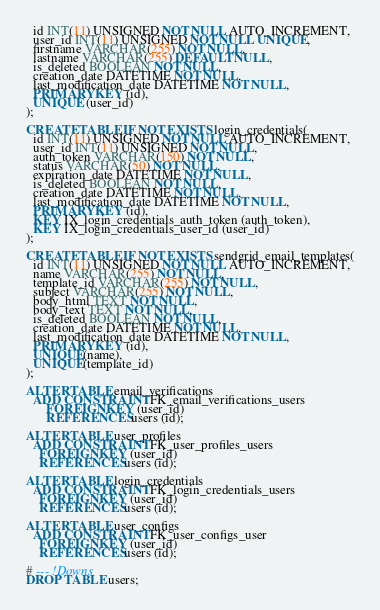<code> <loc_0><loc_0><loc_500><loc_500><_SQL_>  id INT(11) UNSIGNED NOT NULL AUTO_INCREMENT,
  user_id INT(11) UNSIGNED NOT NULL UNIQUE,
  firstname VARCHAR(255) NOT NULL,
  lastname VARCHAR(255) DEFAULT NULL,
  is_deleted BOOLEAN NOT NULL,
  creation_date DATETIME NOT NULL,
  last_modification_date DATETIME NOT NULL,
  PRIMARY KEY (id),
  UNIQUE (user_id)
);

CREATE TABLE IF NOT EXISTS login_credentials(
  id INT(11) UNSIGNED NOT NULL AUTO_INCREMENT,
  user_id INT(11) UNSIGNED NOT NULL,
  auth_token VARCHAR(150) NOT NULL,
  status VARCHAR(50) NOT NULL,
  expiration_date DATETIME NOT NULL,
  is_deleted BOOLEAN NOT NULL,
  creation_date DATETIME NOT NULL,
  last_modification_date DATETIME NOT NULL,
  PRIMARY KEY (id),
  KEY IX_login_credentials_auth_token (auth_token),
  KEY IX_login_credentials_user_id (user_id)
);

CREATE TABLE IF NOT EXISTS sendgrid_email_templates(
  id INT(11) UNSIGNED NOT NULL AUTO_INCREMENT,
  name VARCHAR(255) NOT NULL,
  template_id VARCHAR(255) NOT NULL,
  subject VARCHAR(255) NOT NULL,
  body_html TEXT NOT NULL,
  body_text TEXT NOT NULL,
  is_deleted BOOLEAN NOT NULL,
  creation_date DATETIME NOT NULL,
  last_modification_date DATETIME NOT NULL,
  PRIMARY KEY (id),
  UNIQUE(name),
  UNIQUE(template_id)
);

ALTER TABLE email_verifications
  ADD CONSTRAINT FK_email_verifications_users
      FOREIGN KEY (user_id)
      REFERENCES users (id);

ALTER TABLE user_profiles
  ADD CONSTRAINT FK_user_profiles_users
    FOREIGN KEY (user_id)
    REFERENCES users (id);

ALTER TABLE login_credentials
  ADD CONSTRAINT FK_login_credentials_users
    FOREIGN KEY (user_id)
    REFERENCES users (id);

ALTER TABLE user_configs
  ADD CONSTRAINT FK_user_configs_user
    FOREIGN KEY (user_id)
    REFERENCES users (id);

# --- !Downs
DROP TABLE users;</code> 